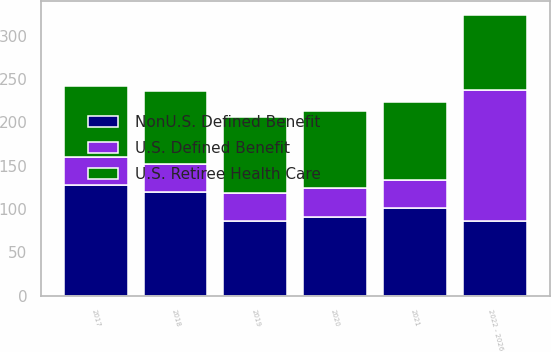Convert chart to OTSL. <chart><loc_0><loc_0><loc_500><loc_500><stacked_bar_chart><ecel><fcel>2017<fcel>2018<fcel>2019<fcel>2020<fcel>2021<fcel>2022 - 2026<nl><fcel>NonU.S. Defined Benefit<fcel>128<fcel>120<fcel>86<fcel>91<fcel>101<fcel>86.5<nl><fcel>U.S. Defined Benefit<fcel>32<fcel>32<fcel>33<fcel>33<fcel>32<fcel>151<nl><fcel>U.S. Retiree Health Care<fcel>82<fcel>84<fcel>87<fcel>89<fcel>91<fcel>86.5<nl></chart> 